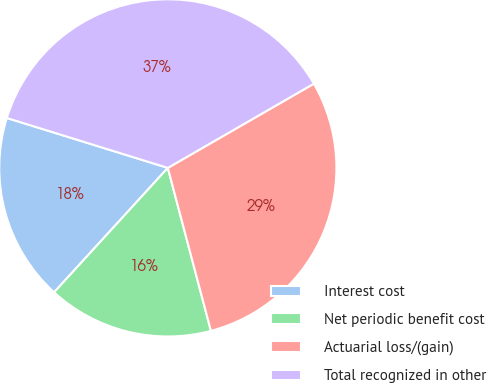Convert chart to OTSL. <chart><loc_0><loc_0><loc_500><loc_500><pie_chart><fcel>Interest cost<fcel>Net periodic benefit cost<fcel>Actuarial loss/(gain)<fcel>Total recognized in other<nl><fcel>18.0%<fcel>15.9%<fcel>29.21%<fcel>36.89%<nl></chart> 